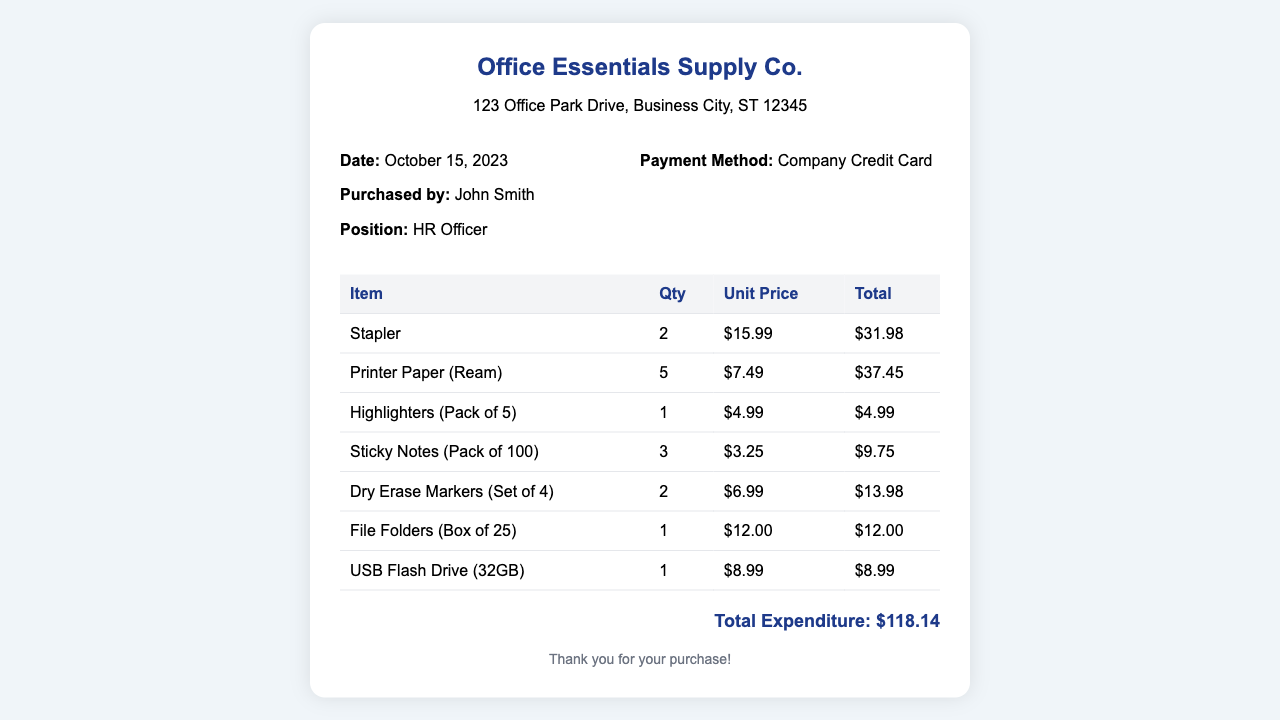what is the date of purchase? The date of purchase is clearly stated in the document, which is October 15, 2023.
Answer: October 15, 2023 who purchased the supplies? The name of the person who made the purchase is mentioned in the document as John Smith.
Answer: John Smith what is the total expenditure? The total expenditure is calculated and displayed prominently at the bottom of the receipt, which is $118.14.
Answer: $118.14 how many USB Flash Drives were purchased? The quantity of USB Flash Drives is listed in the table under the relevant item, which shows 1 unit purchased.
Answer: 1 what is the unit price of Printer Paper? The document specifies the unit price for Printer Paper as $7.49 in the itemized table.
Answer: $7.49 which payment method was used? The payment method used for the purchase is specified as Company Credit Card.
Answer: Company Credit Card how many items were bought in total? By counting the items listed in the table, a total of 7 different office supply items were purchased.
Answer: 7 what is the quantity of Sticky Notes purchased? The quantity of Sticky Notes is directly stated in the item list, showing that 3 packs were bought.
Answer: 3 what is the total cost for Dry Erase Markers? The document lists the total cost for Dry Erase Markers as $13.98 in the itemized section.
Answer: $13.98 